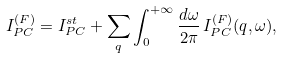<formula> <loc_0><loc_0><loc_500><loc_500>I ^ { ( F ) } _ { P C } = I _ { P C } ^ { s t } + \sum _ { q } \int _ { 0 } ^ { + \infty } \frac { d \omega } { 2 \pi } \, I ^ { ( F ) } _ { P C } ( { q } , \omega ) ,</formula> 